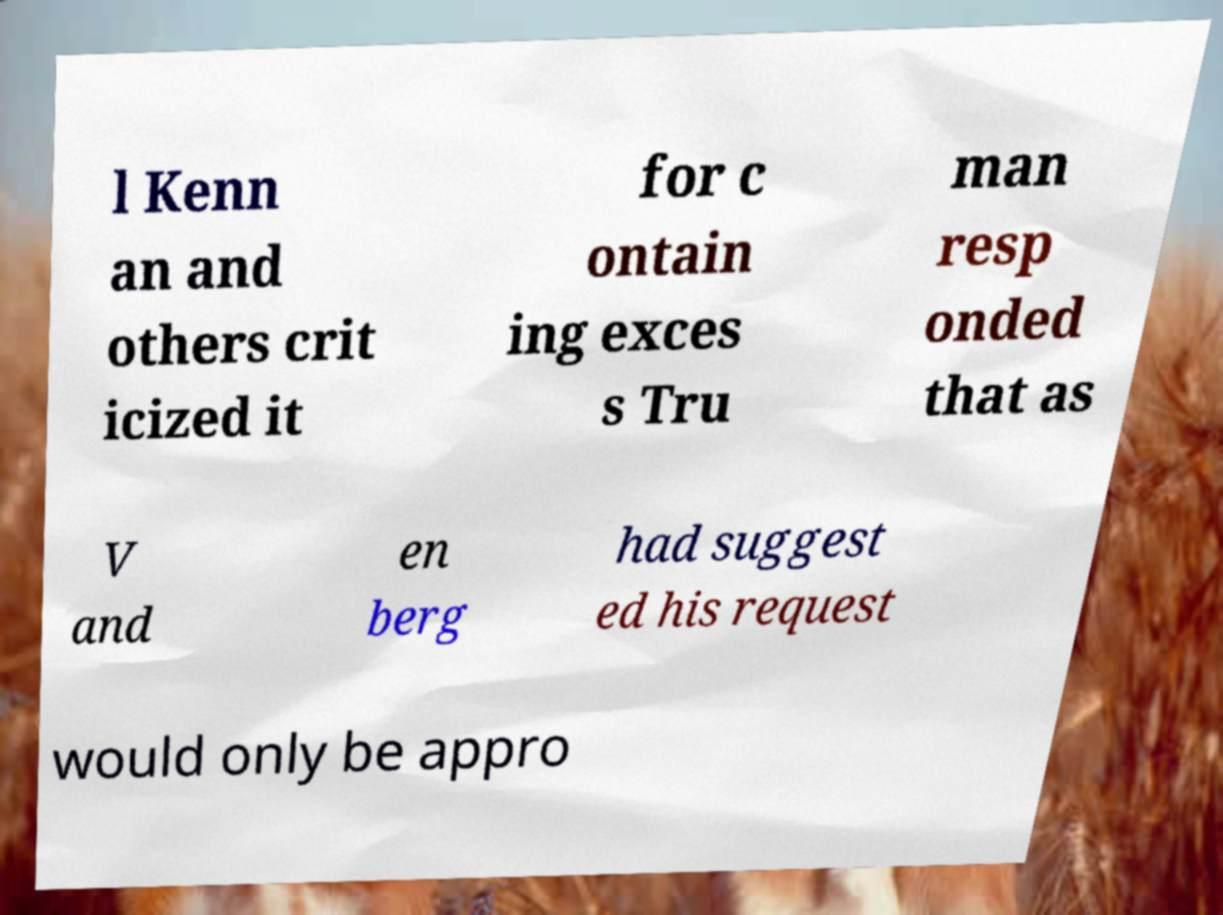Please identify and transcribe the text found in this image. l Kenn an and others crit icized it for c ontain ing exces s Tru man resp onded that as V and en berg had suggest ed his request would only be appro 